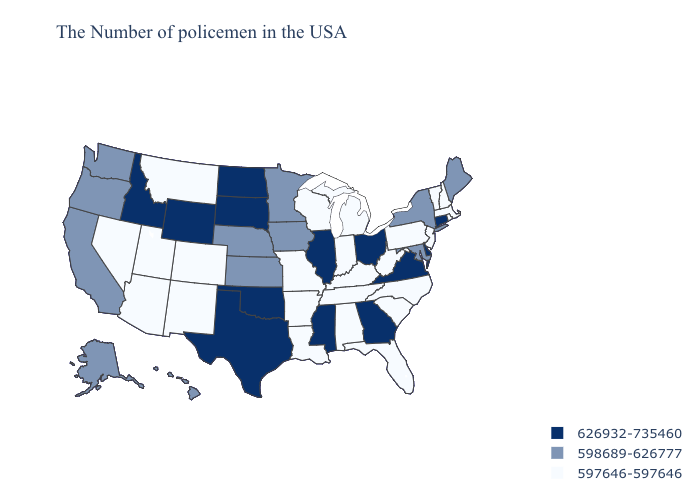Which states hav the highest value in the MidWest?
Concise answer only. Ohio, Illinois, South Dakota, North Dakota. What is the lowest value in states that border New Hampshire?
Keep it brief. 597646-597646. Does Nebraska have a higher value than Minnesota?
Give a very brief answer. No. What is the highest value in the West ?
Write a very short answer. 626932-735460. How many symbols are there in the legend?
Be succinct. 3. What is the value of Wisconsin?
Keep it brief. 597646-597646. Name the states that have a value in the range 598689-626777?
Keep it brief. Maine, New York, Maryland, Minnesota, Iowa, Kansas, Nebraska, California, Washington, Oregon, Alaska, Hawaii. Name the states that have a value in the range 597646-597646?
Short answer required. Massachusetts, Rhode Island, New Hampshire, Vermont, New Jersey, Pennsylvania, North Carolina, South Carolina, West Virginia, Florida, Michigan, Kentucky, Indiana, Alabama, Tennessee, Wisconsin, Louisiana, Missouri, Arkansas, Colorado, New Mexico, Utah, Montana, Arizona, Nevada. What is the highest value in the USA?
Be succinct. 626932-735460. Does Michigan have a higher value than Virginia?
Answer briefly. No. Name the states that have a value in the range 598689-626777?
Quick response, please. Maine, New York, Maryland, Minnesota, Iowa, Kansas, Nebraska, California, Washington, Oregon, Alaska, Hawaii. What is the value of California?
Keep it brief. 598689-626777. Does California have the lowest value in the West?
Give a very brief answer. No. Among the states that border Alabama , does Tennessee have the lowest value?
Give a very brief answer. Yes. Which states have the highest value in the USA?
Quick response, please. Connecticut, Delaware, Virginia, Ohio, Georgia, Illinois, Mississippi, Oklahoma, Texas, South Dakota, North Dakota, Wyoming, Idaho. 